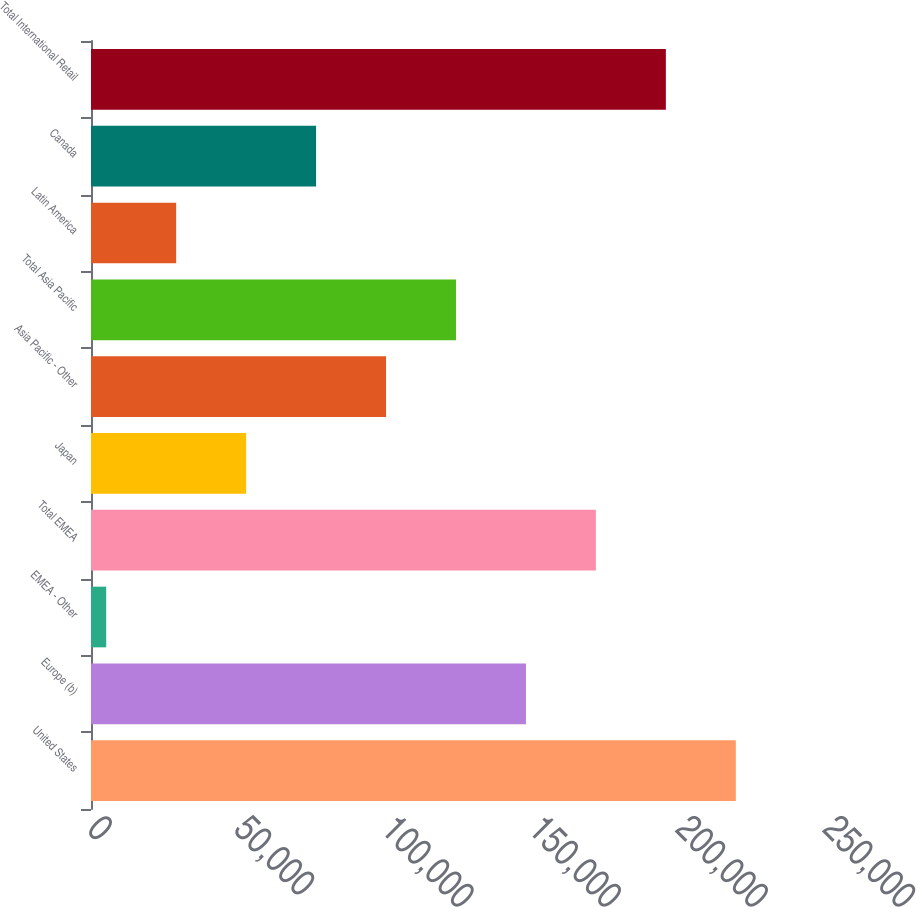<chart> <loc_0><loc_0><loc_500><loc_500><bar_chart><fcel>United States<fcel>Europe (b)<fcel>EMEA - Other<fcel>Total EMEA<fcel>Japan<fcel>Asia Pacific - Other<fcel>Total Asia Pacific<fcel>Latin America<fcel>Canada<fcel>Total International Retail<nl><fcel>219025<fcel>147738<fcel>5162<fcel>171500<fcel>52687.2<fcel>100212<fcel>123975<fcel>28924.6<fcel>76449.8<fcel>195263<nl></chart> 